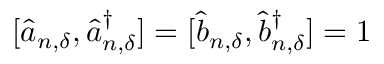Convert formula to latex. <formula><loc_0><loc_0><loc_500><loc_500>[ \hat { a } _ { n , { \delta } } , \hat { a } _ { n , { \delta } } ^ { \dagger } ] = [ \hat { b } _ { n , { \delta } } , \hat { b } _ { n , { \delta } } ^ { \dagger } ] = 1</formula> 